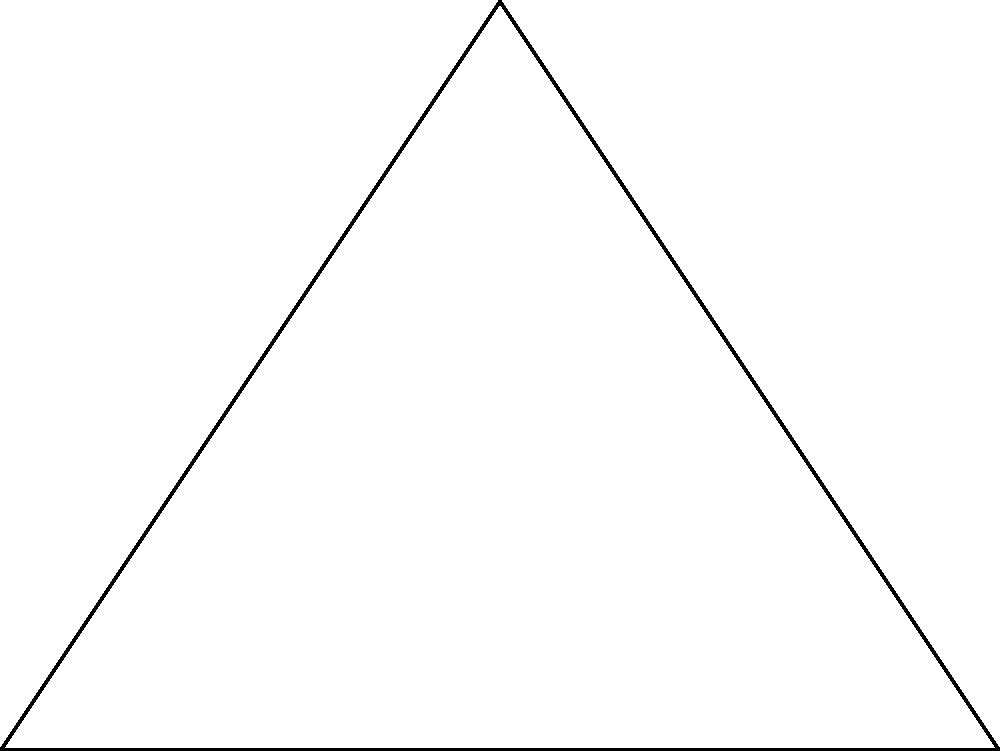As part of a habitat restoration project, you need to calculate the angles of a triangular plot of land. Given that the plot forms a right-angled triangle with one side measuring 4 km and another 3 km, what is the measure of the largest angle in the triangle? Let's approach this step-by-step:

1) We have a right-angled triangle, so one angle is already known to be 90°.

2) In a right-angled triangle, the longest side is always opposite the right angle and is called the hypotenuse.

3) We can find the length of the hypotenuse using the Pythagorean theorem:

   $$a^2 + b^2 = c^2$$
   
   where $c$ is the hypotenuse and $a$ and $b$ are the other two sides.

4) Substituting our known values:

   $$3^2 + 4^2 = c^2$$
   $$9 + 16 = c^2$$
   $$25 = c^2$$
   $$c = 5$$

5) Now we can use trigonometry to find the other angles. Let's focus on the largest angle (other than the right angle).

6) The largest angle will be opposite the longest side (excluding the hypotenuse). In this case, it's opposite the 4 km side.

7) We can use the sine function to find this angle:

   $$\sin(\theta) = \frac{\text{opposite}}{\text{hypotenuse}} = \frac{4}{5}$$

8) To get the angle, we need to take the inverse sine (arcsin):

   $$\theta = \arcsin(\frac{4}{5})$$

9) Using a calculator or trigonometric tables, we find:

   $$\theta \approx 53.13°$$

Therefore, the largest angle in the triangle (excluding the right angle) is approximately 53.13°.
Answer: 53.13° 